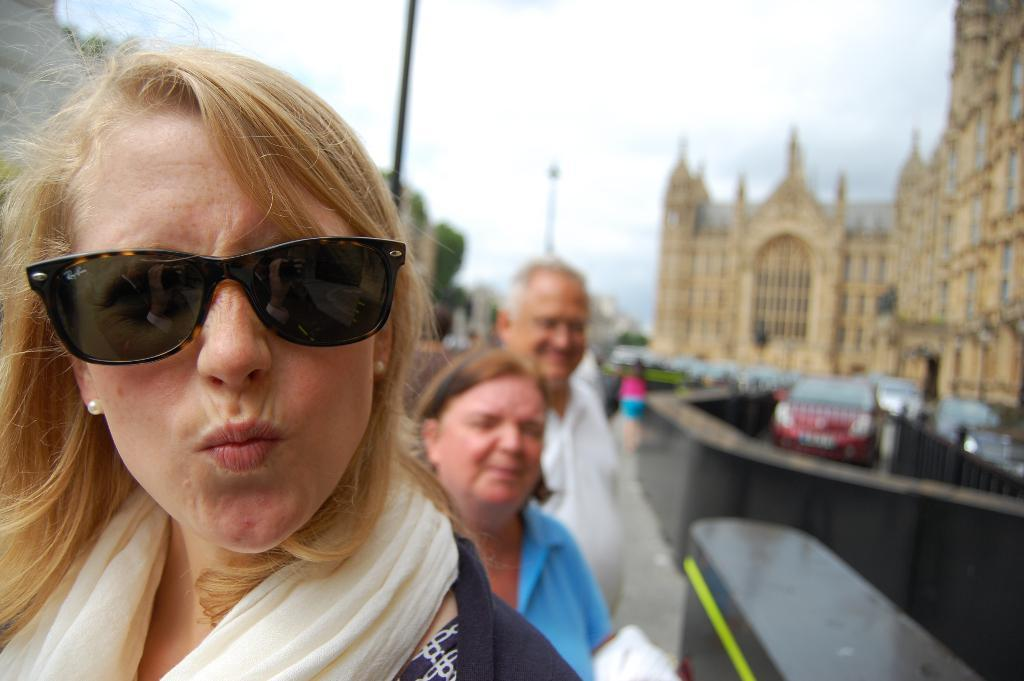What is the main subject in the foreground of the image? There is a crowd in the foreground of the image. What can be seen in the background of the image? There are vehicles on the road, trees, buildings, and the sky visible in the background of the image. What is the time of day when the image was taken? The image was taken during the day. What title does the crowd in the image hold? There is no indication in the image that the crowd holds any specific title. 